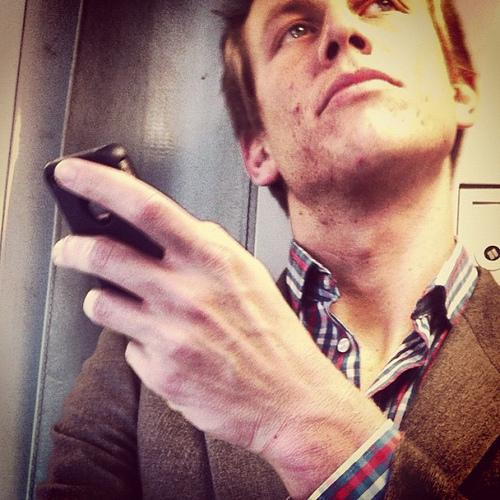Question: what color jacket is the man wearing?
Choices:
A. Blue.
B. Red.
C. Brown.
D. Yellow.
Answer with the letter. Answer: C Question: what type of jewelry is the man wearing?
Choices:
A. A ring.
B. None.
C. A medallion.
D. A neck chain.
Answer with the letter. Answer: B Question: who is wearing a plaid shirt?
Choices:
A. Woman.
B. The man.
C. Man and woman.
D. Models.
Answer with the letter. Answer: B Question: what print shirt is the man wearing?
Choices:
A. Animal.
B. Stripes.
C. Plaid.
D. Diamonds.
Answer with the letter. Answer: C 